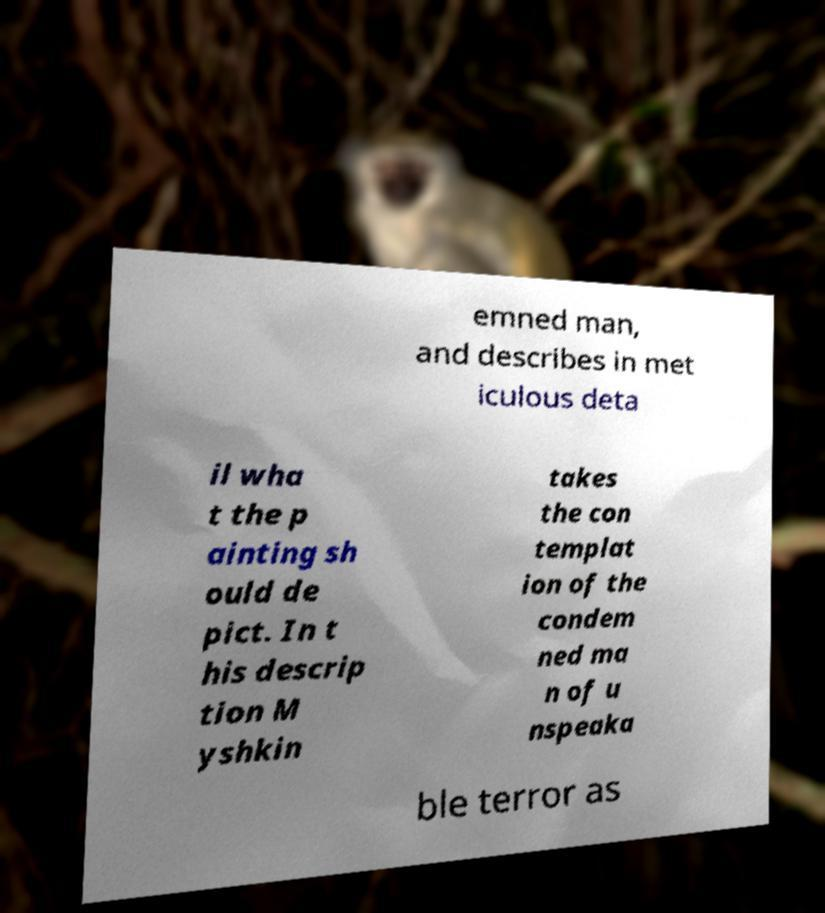Please read and relay the text visible in this image. What does it say? emned man, and describes in met iculous deta il wha t the p ainting sh ould de pict. In t his descrip tion M yshkin takes the con templat ion of the condem ned ma n of u nspeaka ble terror as 